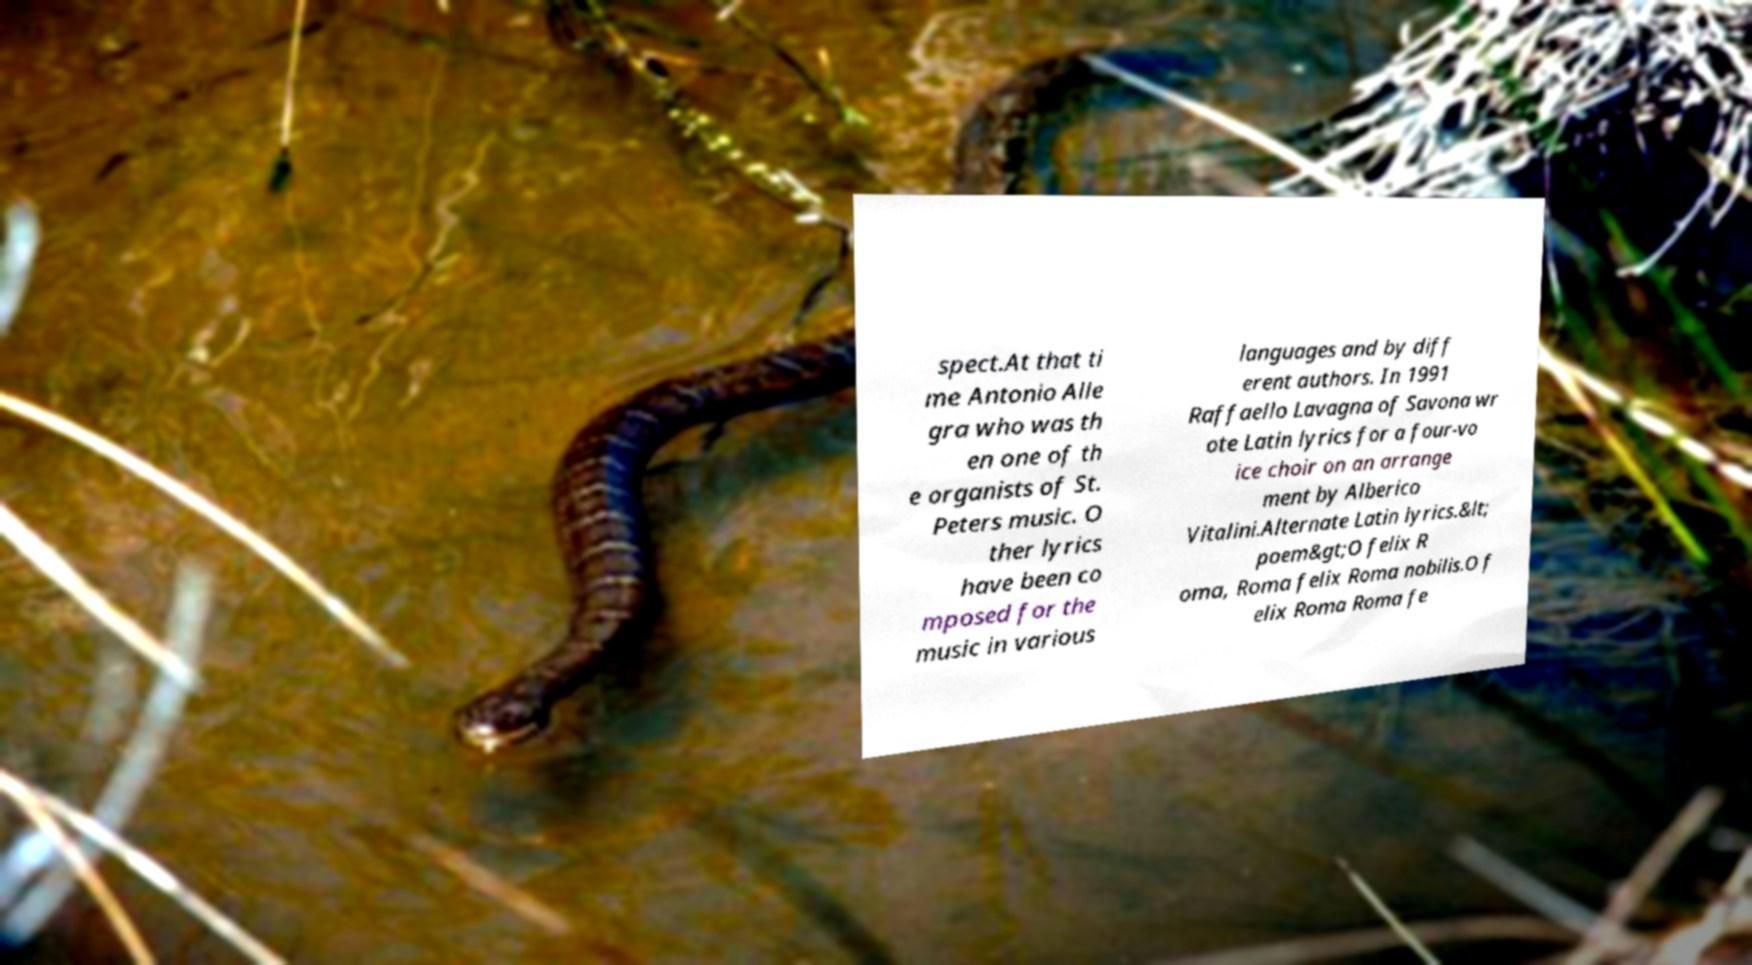I need the written content from this picture converted into text. Can you do that? spect.At that ti me Antonio Alle gra who was th en one of th e organists of St. Peters music. O ther lyrics have been co mposed for the music in various languages and by diff erent authors. In 1991 Raffaello Lavagna of Savona wr ote Latin lyrics for a four-vo ice choir on an arrange ment by Alberico Vitalini.Alternate Latin lyrics.&lt; poem&gt;O felix R oma, Roma felix Roma nobilis.O f elix Roma Roma fe 